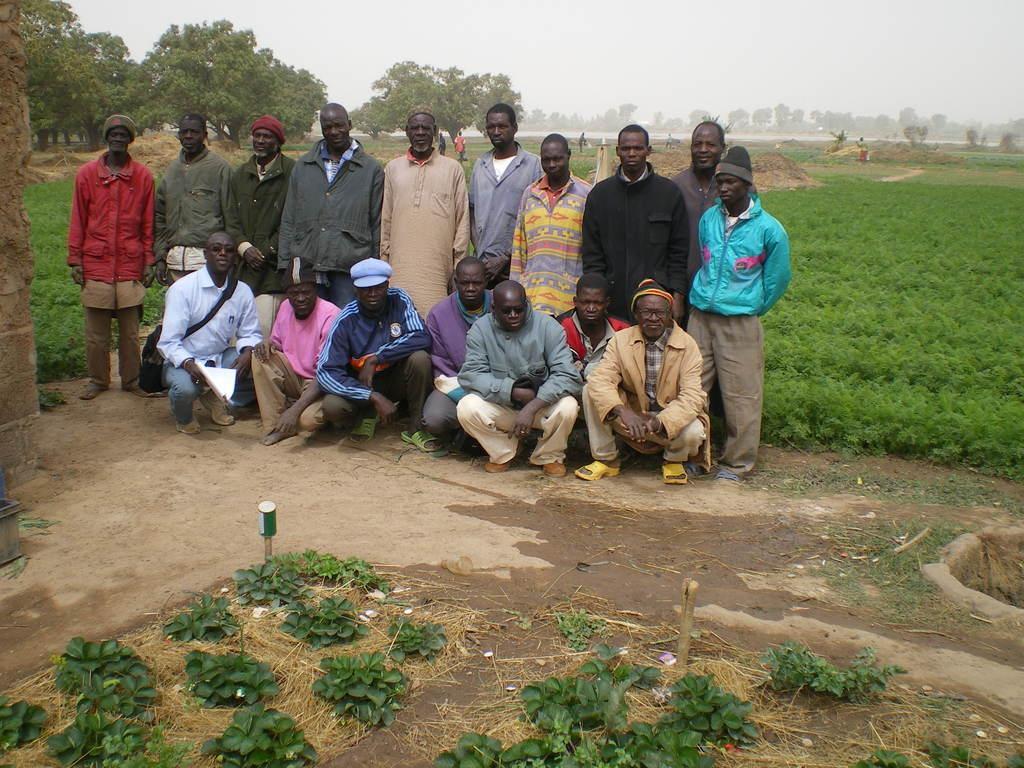Could you give a brief overview of what you see in this image? In the image in the center we can see few people were sitting and standing. And we can see few people were wearing hat. In the bottom of the image we can see wall,black color object,poles,can,dry grass and plants. In the background we can see sky,clouds,trees,plants,grass and few peoples were standing. 